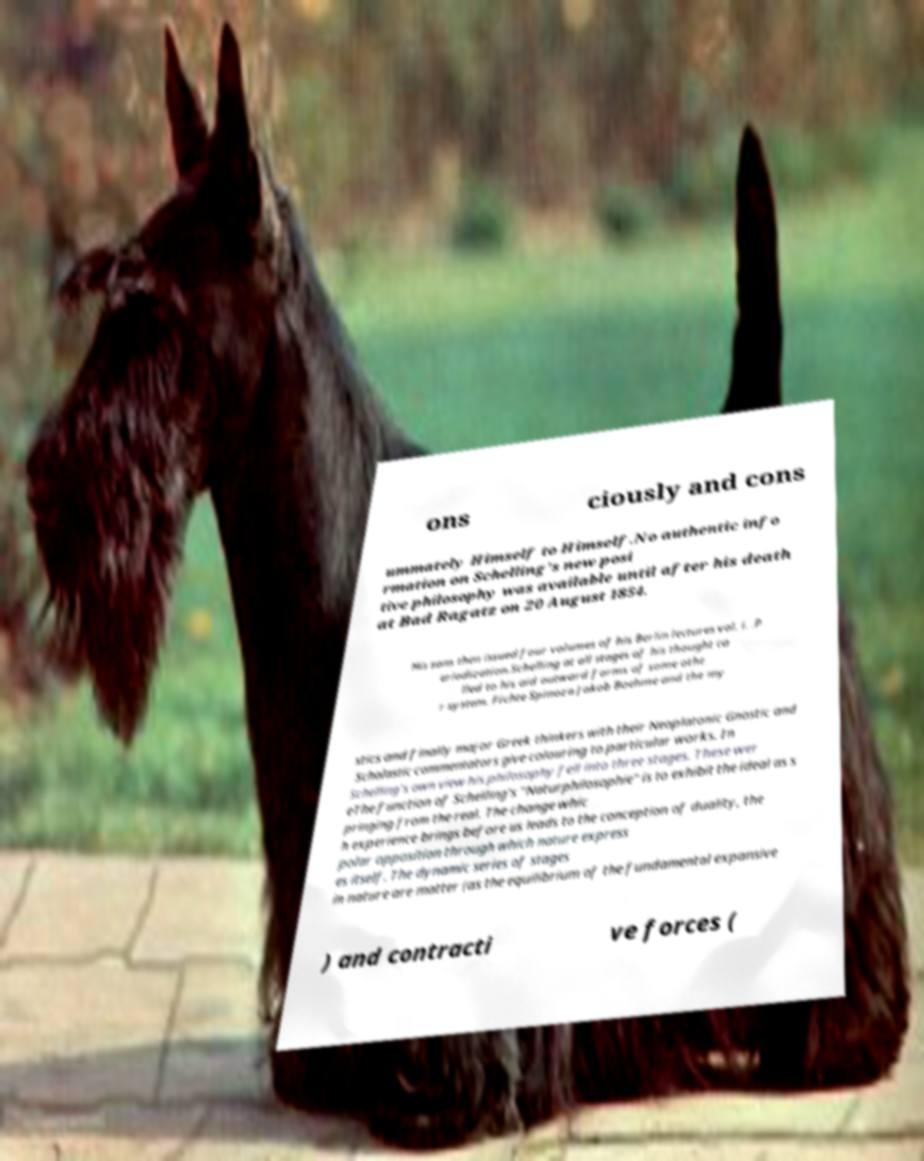For documentation purposes, I need the text within this image transcribed. Could you provide that? ons ciously and cons ummately Himself to Himself.No authentic info rmation on Schelling's new posi tive philosophy was available until after his death at Bad Ragatz on 20 August 1854. His sons then issued four volumes of his Berlin lectures vol. i. .P eriodization.Schelling at all stages of his thought ca lled to his aid outward forms of some othe r system. Fichte Spinoza Jakob Boehme and the my stics and finally major Greek thinkers with their Neoplatonic Gnostic and Scholastic commentators give colouring to particular works. In Schelling's own view his philosophy fell into three stages. These wer eThe function of Schelling's "Naturphilosophie" is to exhibit the ideal as s pringing from the real. The change whic h experience brings before us leads to the conception of duality, the polar opposition through which nature express es itself. The dynamic series of stages in nature are matter (as the equilibrium of the fundamental expansive ) and contracti ve forces ( 